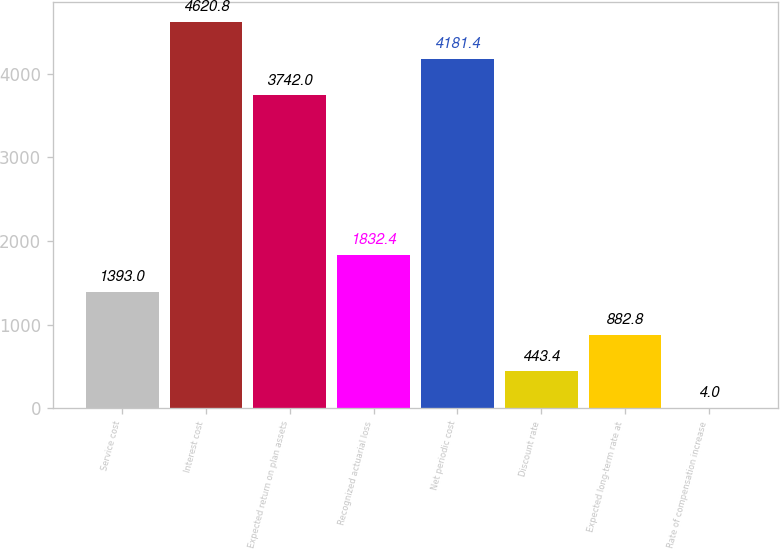Convert chart to OTSL. <chart><loc_0><loc_0><loc_500><loc_500><bar_chart><fcel>Service cost<fcel>Interest cost<fcel>Expected return on plan assets<fcel>Recognized actuarial loss<fcel>Net periodic cost<fcel>Discount rate<fcel>Expected long-term rate at<fcel>Rate of compensation increase<nl><fcel>1393<fcel>4620.8<fcel>3742<fcel>1832.4<fcel>4181.4<fcel>443.4<fcel>882.8<fcel>4<nl></chart> 